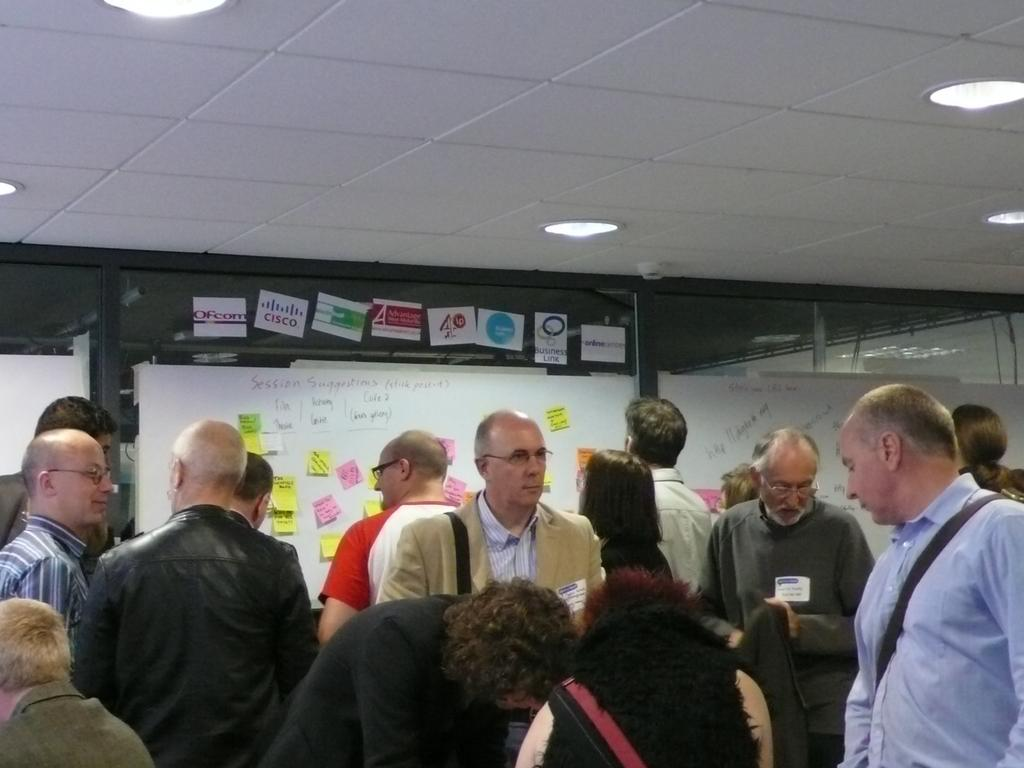What can be seen at the bottom of the image? There is a group of people at the bottom of the image. What is visible in the background of the image? There are posters, stickers, and glass objects in the background of the image. What is visible at the top of the image? The ceiling is visible at the top of the image, and lights are present there. What type of tooth is being used as a decoration in the image? There is no tooth present in the image; it is not being used as a decoration. What type of humor can be seen in the posters in the image? The posters in the image do not contain any humor; they are simply visual elements in the background. 